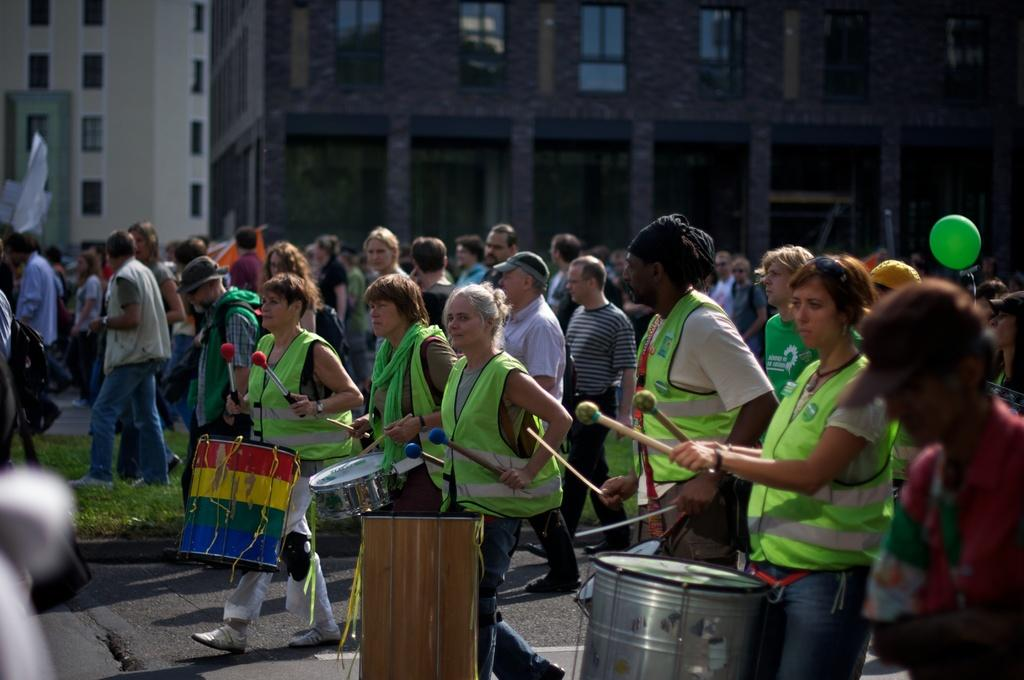What are the people in the image doing? Some people are holding musical instruments. Can you describe any other objects or features in the image? Yes, there is a balloon in the background of the image, as well as buildings and a flag. What type of wool is being used to create the place in the image? There is no wool or place mentioned in the image; it features people holding musical instruments and a background with a balloon, buildings, and a flag. 